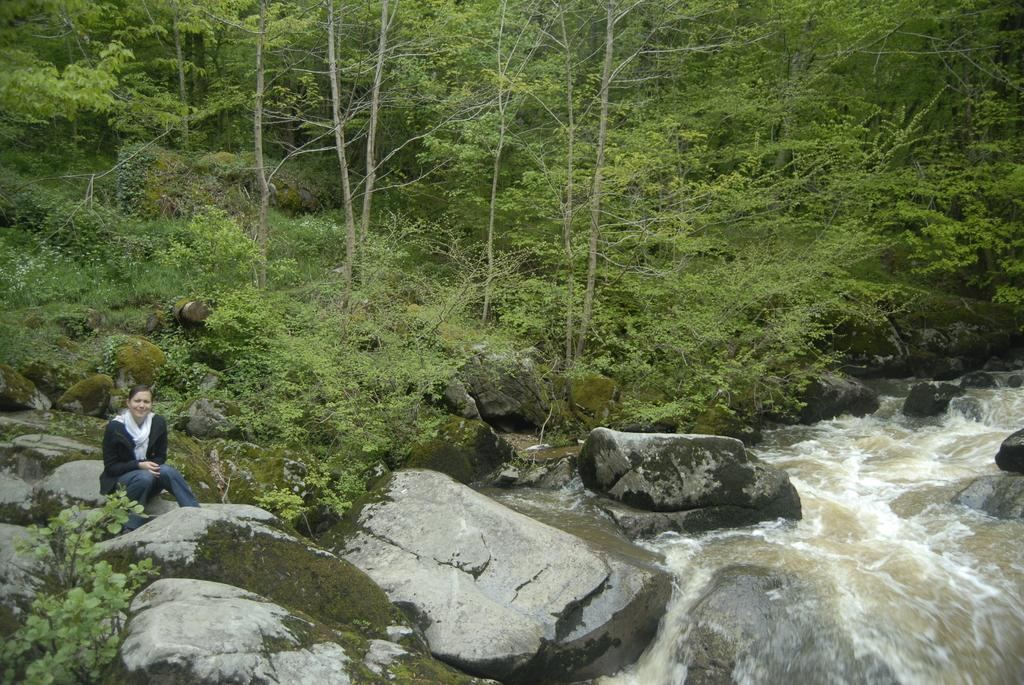What type of natural formation can be seen in the image? There are rocks in the image. What is happening with the water in the image? Water is flowing through the rocks. Can you describe the lady's position in the image? There is a lady sitting on a rock on the left side of the image. What can be seen in the background of the image? There are trees visible in the background of the image. What type of cork can be seen floating in the water in the image? There is no cork present in the image; it features rocks and water flowing through them. What is the lady arguing about with the trees in the background? There is no argument depicted in the image; the lady is sitting on a rock, and the trees are in the background. 